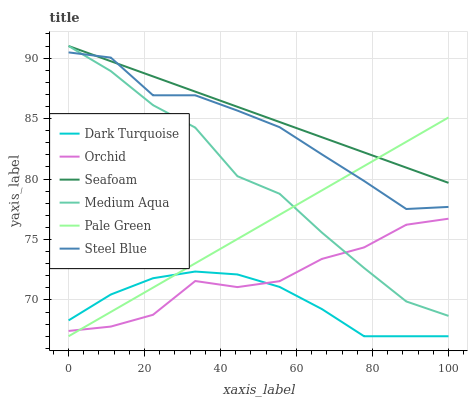Does Dark Turquoise have the minimum area under the curve?
Answer yes or no. Yes. Does Seafoam have the maximum area under the curve?
Answer yes or no. Yes. Does Steel Blue have the minimum area under the curve?
Answer yes or no. No. Does Steel Blue have the maximum area under the curve?
Answer yes or no. No. Is Pale Green the smoothest?
Answer yes or no. Yes. Is Orchid the roughest?
Answer yes or no. Yes. Is Steel Blue the smoothest?
Answer yes or no. No. Is Steel Blue the roughest?
Answer yes or no. No. Does Steel Blue have the lowest value?
Answer yes or no. No. Does Medium Aqua have the highest value?
Answer yes or no. Yes. Does Steel Blue have the highest value?
Answer yes or no. No. Is Orchid less than Steel Blue?
Answer yes or no. Yes. Is Steel Blue greater than Orchid?
Answer yes or no. Yes. Does Seafoam intersect Steel Blue?
Answer yes or no. Yes. Is Seafoam less than Steel Blue?
Answer yes or no. No. Is Seafoam greater than Steel Blue?
Answer yes or no. No. Does Orchid intersect Steel Blue?
Answer yes or no. No. 